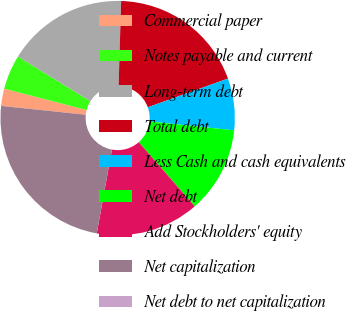<chart> <loc_0><loc_0><loc_500><loc_500><pie_chart><fcel>Commercial paper<fcel>Notes payable and current<fcel>Long-term debt<fcel>Total debt<fcel>Less Cash and cash equivalents<fcel>Net debt<fcel>Add Stockholders' equity<fcel>Net capitalization<fcel>Net debt to net capitalization<nl><fcel>2.38%<fcel>4.76%<fcel>16.67%<fcel>19.05%<fcel>7.14%<fcel>11.9%<fcel>14.28%<fcel>23.81%<fcel>0.0%<nl></chart> 